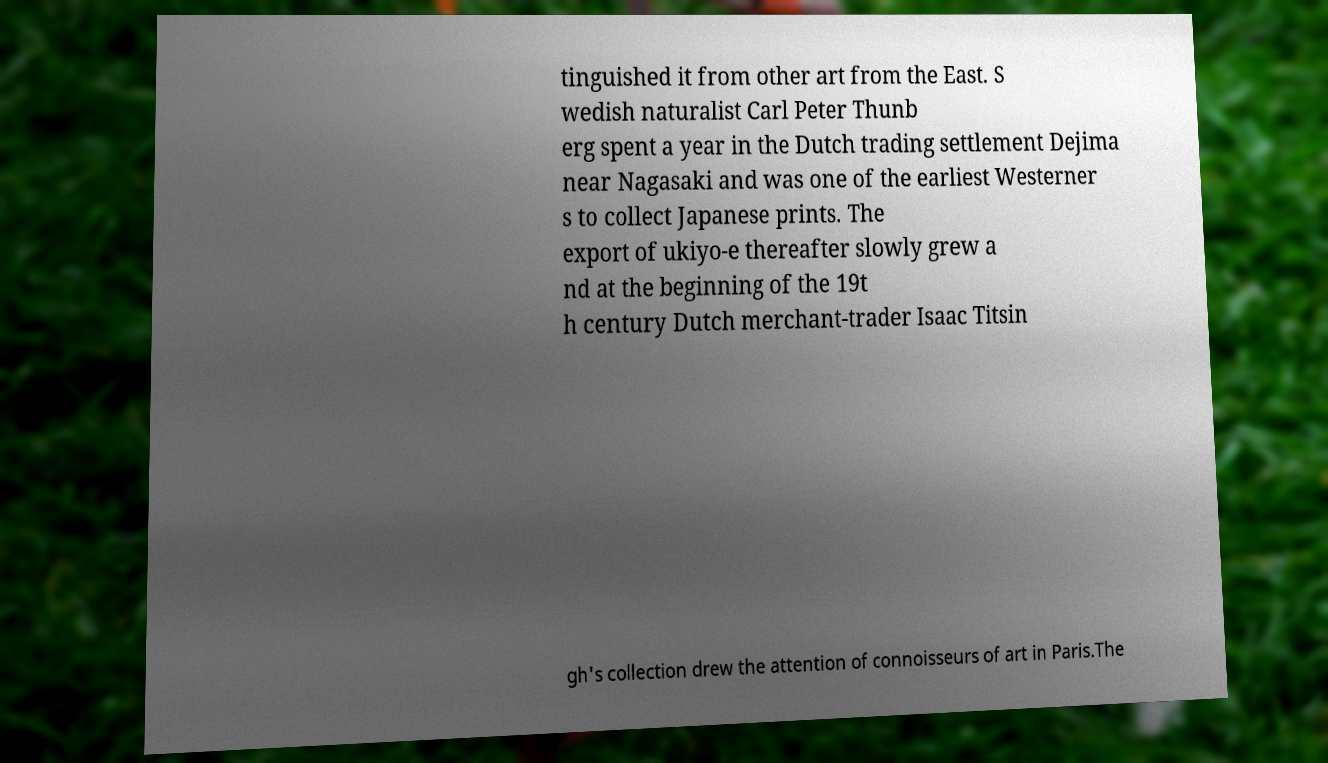Please read and relay the text visible in this image. What does it say? tinguished it from other art from the East. S wedish naturalist Carl Peter Thunb erg spent a year in the Dutch trading settlement Dejima near Nagasaki and was one of the earliest Westerner s to collect Japanese prints. The export of ukiyo-e thereafter slowly grew a nd at the beginning of the 19t h century Dutch merchant-trader Isaac Titsin gh's collection drew the attention of connoisseurs of art in Paris.The 